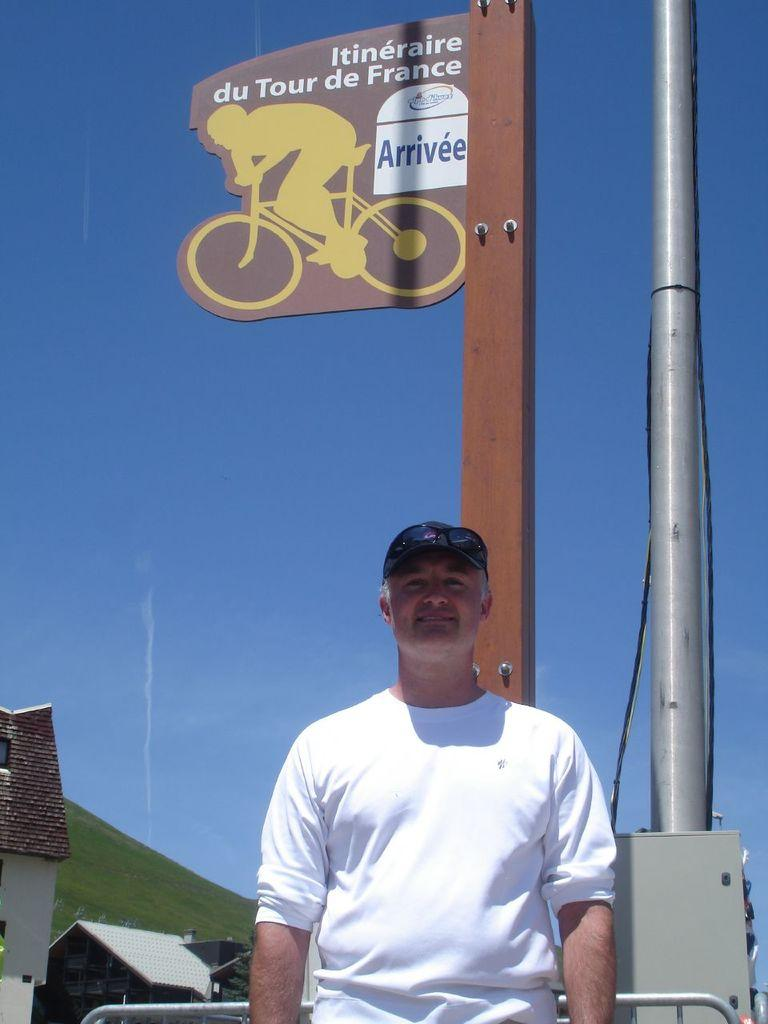Who or what is located in the center of the image? There is a man in the center of the image. What else is in the center of the image besides the man? There is a sign pole in the center of the image. What type of structures can be seen in the bottom left side of the image? There are houses in the bottom left side of the image. What type of scent can be detected in the image? There is no information about a scent in the image, so it cannot be determined. 